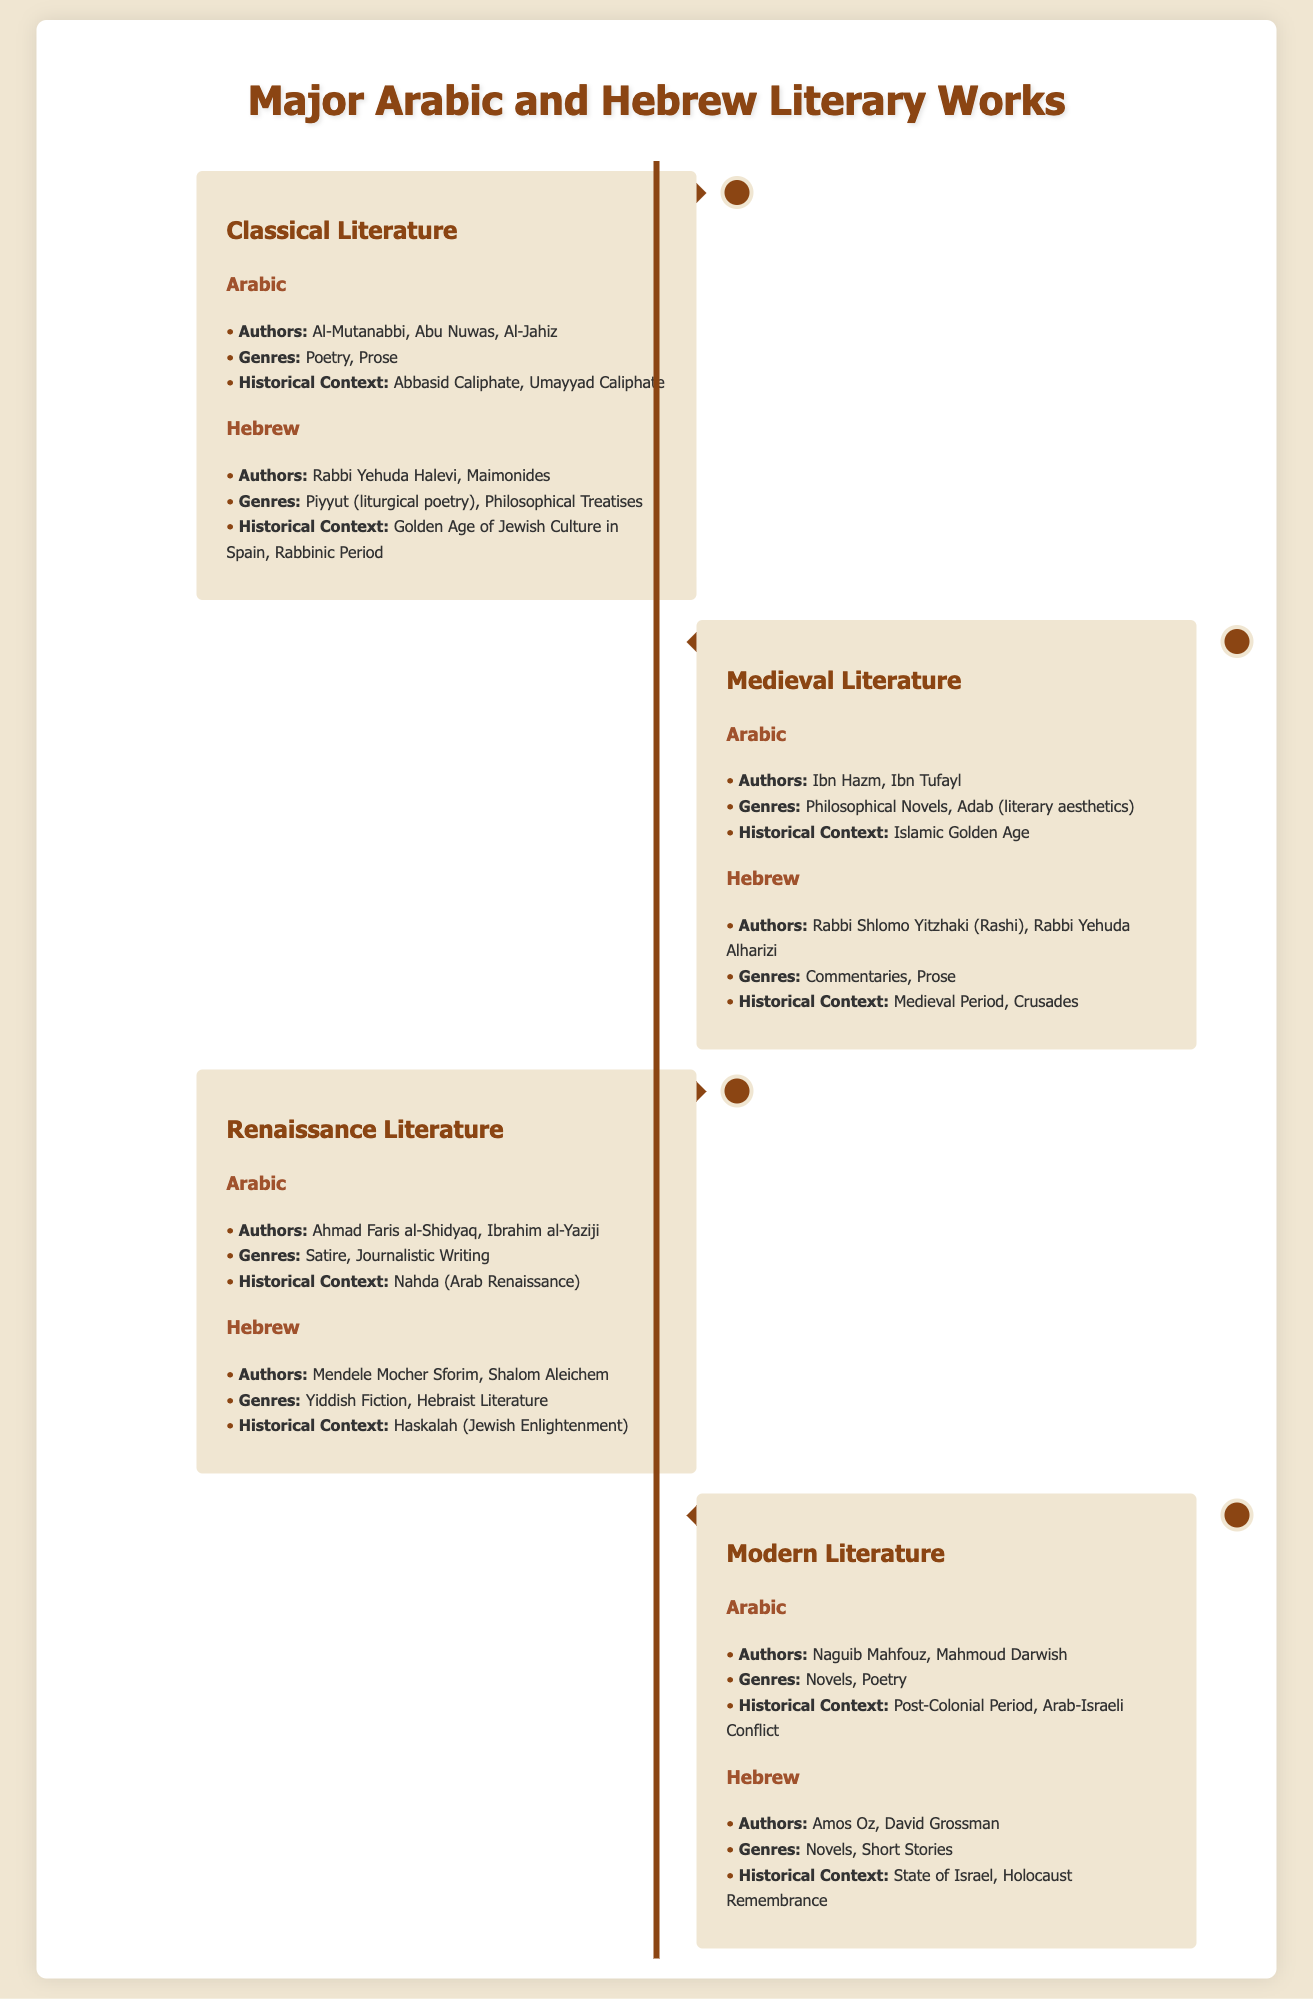What authors are included in Classical Arabic Literature? The document lists Al-Mutanabbi, Abu Nuwas, and Al-Jahiz as authors of Classical Arabic Literature.
Answer: Al-Mutanabbi, Abu Nuwas, Al-Jahiz Which genre is associated with Medieval Hebrew Literature? The document mentions Commentaries and Prose as genres in Medieval Hebrew Literature.
Answer: Commentaries, Prose Who are the authors in Modern Hebrew Literature? The document states that Amos Oz and David Grossman are authors in Modern Hebrew Literature.
Answer: Amos Oz, David Grossman What historical context is associated with Renaissance Arabic Literature? Nahda (Arab Renaissance) is described as the historical context for Renaissance Arabic Literature.
Answer: Nahda (Arab Renaissance) Which genre is mentioned for Classical Hebrew Literature? The document indicates that Piyyut (liturgical poetry) is a genre in Classical Hebrew Literature.
Answer: Piyyut How many authors are listed under Medieval Arabic Literature? The document specifies two authors, Ibn Hazm and Ibn Tufayl, under Medieval Arabic Literature.
Answer: Two What is the common theme in Modern Arabic Literature? The historical context that relates to Modern Arabic Literature is post-colonial issues and conflict in the region.
Answer: Post-Colonial Period, Arab-Israeli Conflict Which period features authors like Mendele Mocher Sforim and Shalom Aleichem? The document associates these authors with Renaissance Literature, indicating their contribution during this time.
Answer: Renaissance Literature What type of literary work is mainly found in the Classical Arabic genre? The most prevalent literary works from Classical Arabic focus on Poetry and Prose.
Answer: Poetry, Prose 